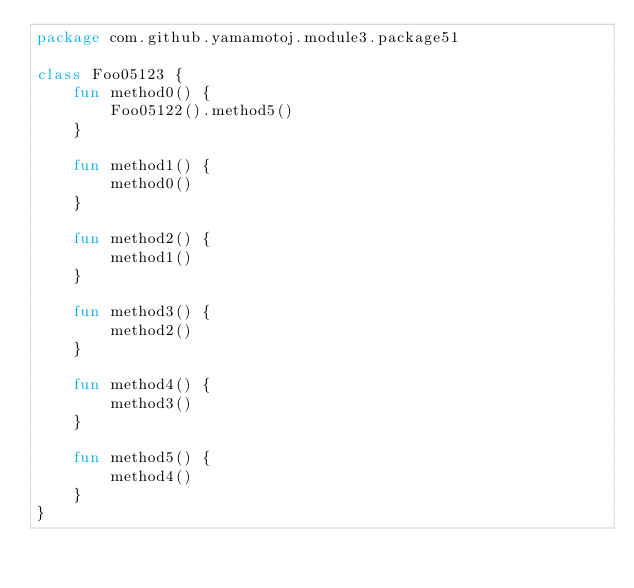<code> <loc_0><loc_0><loc_500><loc_500><_Kotlin_>package com.github.yamamotoj.module3.package51

class Foo05123 {
    fun method0() {
        Foo05122().method5()
    }

    fun method1() {
        method0()
    }

    fun method2() {
        method1()
    }

    fun method3() {
        method2()
    }

    fun method4() {
        method3()
    }

    fun method5() {
        method4()
    }
}
</code> 